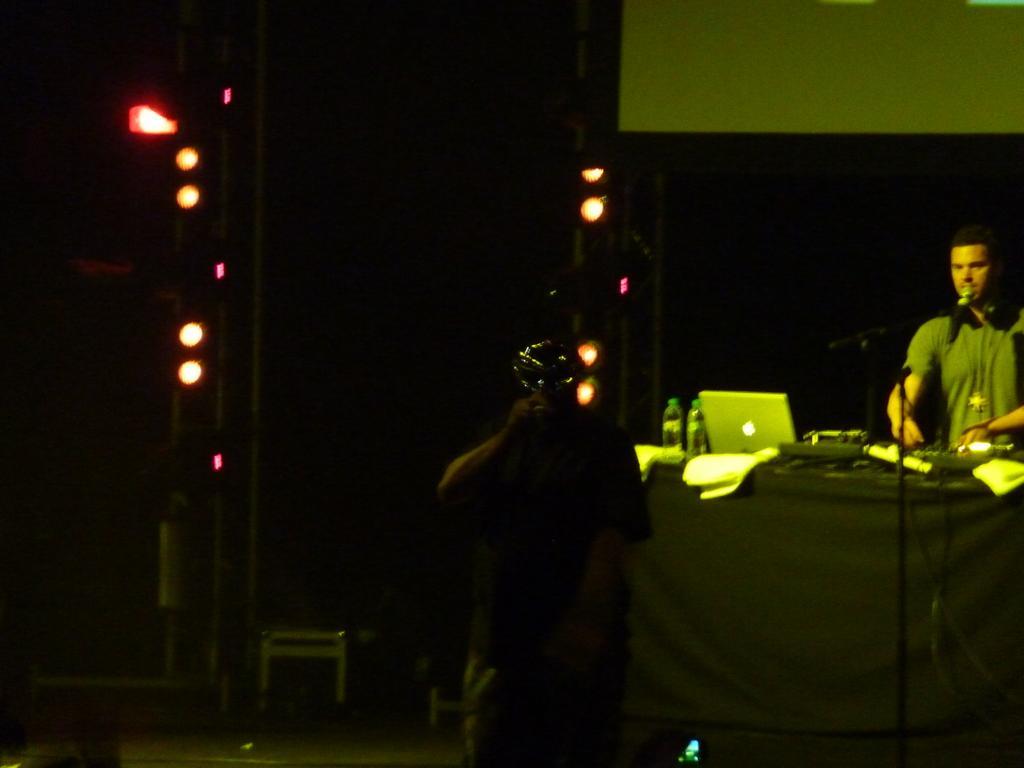In one or two sentences, can you explain what this image depicts? Here in this picture in the right side we can see a person standing over a place and in front of him we can see a table, on which we can see laptop, bottles and other music system and microphone present and in the middle we can see a person, who is clicking picture with camera in his hand and behind him we can see stools present and we can also see colorful lights present. 